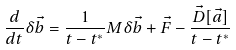<formula> <loc_0><loc_0><loc_500><loc_500>\frac { d } { d t } \delta \vec { b } = \frac { 1 } { t - t ^ { * } } M \delta \vec { b } + \vec { F } - \frac { \vec { D } [ \vec { a } ] } { t - t ^ { * } }</formula> 